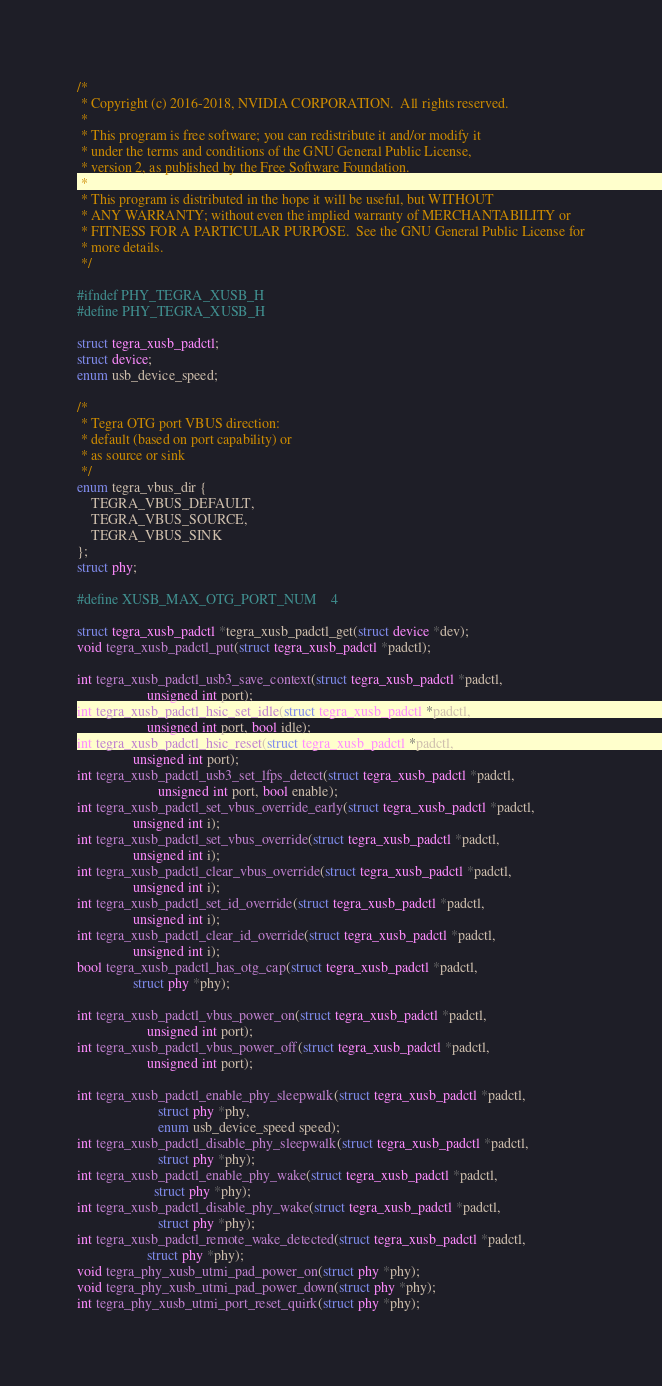Convert code to text. <code><loc_0><loc_0><loc_500><loc_500><_C_>/*
 * Copyright (c) 2016-2018, NVIDIA CORPORATION.  All rights reserved.
 *
 * This program is free software; you can redistribute it and/or modify it
 * under the terms and conditions of the GNU General Public License,
 * version 2, as published by the Free Software Foundation.
 *
 * This program is distributed in the hope it will be useful, but WITHOUT
 * ANY WARRANTY; without even the implied warranty of MERCHANTABILITY or
 * FITNESS FOR A PARTICULAR PURPOSE.  See the GNU General Public License for
 * more details.
 */

#ifndef PHY_TEGRA_XUSB_H
#define PHY_TEGRA_XUSB_H

struct tegra_xusb_padctl;
struct device;
enum usb_device_speed;

/*
 * Tegra OTG port VBUS direction:
 * default (based on port capability) or
 * as source or sink
 */
enum tegra_vbus_dir {
	TEGRA_VBUS_DEFAULT,
	TEGRA_VBUS_SOURCE,
	TEGRA_VBUS_SINK
};
struct phy;

#define XUSB_MAX_OTG_PORT_NUM	4

struct tegra_xusb_padctl *tegra_xusb_padctl_get(struct device *dev);
void tegra_xusb_padctl_put(struct tegra_xusb_padctl *padctl);

int tegra_xusb_padctl_usb3_save_context(struct tegra_xusb_padctl *padctl,
					unsigned int port);
int tegra_xusb_padctl_hsic_set_idle(struct tegra_xusb_padctl *padctl,
				    unsigned int port, bool idle);
int tegra_xusb_padctl_hsic_reset(struct tegra_xusb_padctl *padctl,
				unsigned int port);
int tegra_xusb_padctl_usb3_set_lfps_detect(struct tegra_xusb_padctl *padctl,
					   unsigned int port, bool enable);
int tegra_xusb_padctl_set_vbus_override_early(struct tegra_xusb_padctl *padctl,
				unsigned int i);
int tegra_xusb_padctl_set_vbus_override(struct tegra_xusb_padctl *padctl,
				unsigned int i);
int tegra_xusb_padctl_clear_vbus_override(struct tegra_xusb_padctl *padctl,
				unsigned int i);
int tegra_xusb_padctl_set_id_override(struct tegra_xusb_padctl *padctl,
				unsigned int i);
int tegra_xusb_padctl_clear_id_override(struct tegra_xusb_padctl *padctl,
				unsigned int i);
bool tegra_xusb_padctl_has_otg_cap(struct tegra_xusb_padctl *padctl,
				struct phy *phy);

int tegra_xusb_padctl_vbus_power_on(struct tegra_xusb_padctl *padctl,
					unsigned int port);
int tegra_xusb_padctl_vbus_power_off(struct tegra_xusb_padctl *padctl,
					unsigned int port);

int tegra_xusb_padctl_enable_phy_sleepwalk(struct tegra_xusb_padctl *padctl,
					   struct phy *phy,
					   enum usb_device_speed speed);
int tegra_xusb_padctl_disable_phy_sleepwalk(struct tegra_xusb_padctl *padctl,
					   struct phy *phy);
int tegra_xusb_padctl_enable_phy_wake(struct tegra_xusb_padctl *padctl,
				      struct phy *phy);
int tegra_xusb_padctl_disable_phy_wake(struct tegra_xusb_padctl *padctl,
				       struct phy *phy);
int tegra_xusb_padctl_remote_wake_detected(struct tegra_xusb_padctl *padctl,
					struct phy *phy);
void tegra_phy_xusb_utmi_pad_power_on(struct phy *phy);
void tegra_phy_xusb_utmi_pad_power_down(struct phy *phy);
int tegra_phy_xusb_utmi_port_reset_quirk(struct phy *phy);</code> 